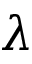<formula> <loc_0><loc_0><loc_500><loc_500>\lambda</formula> 